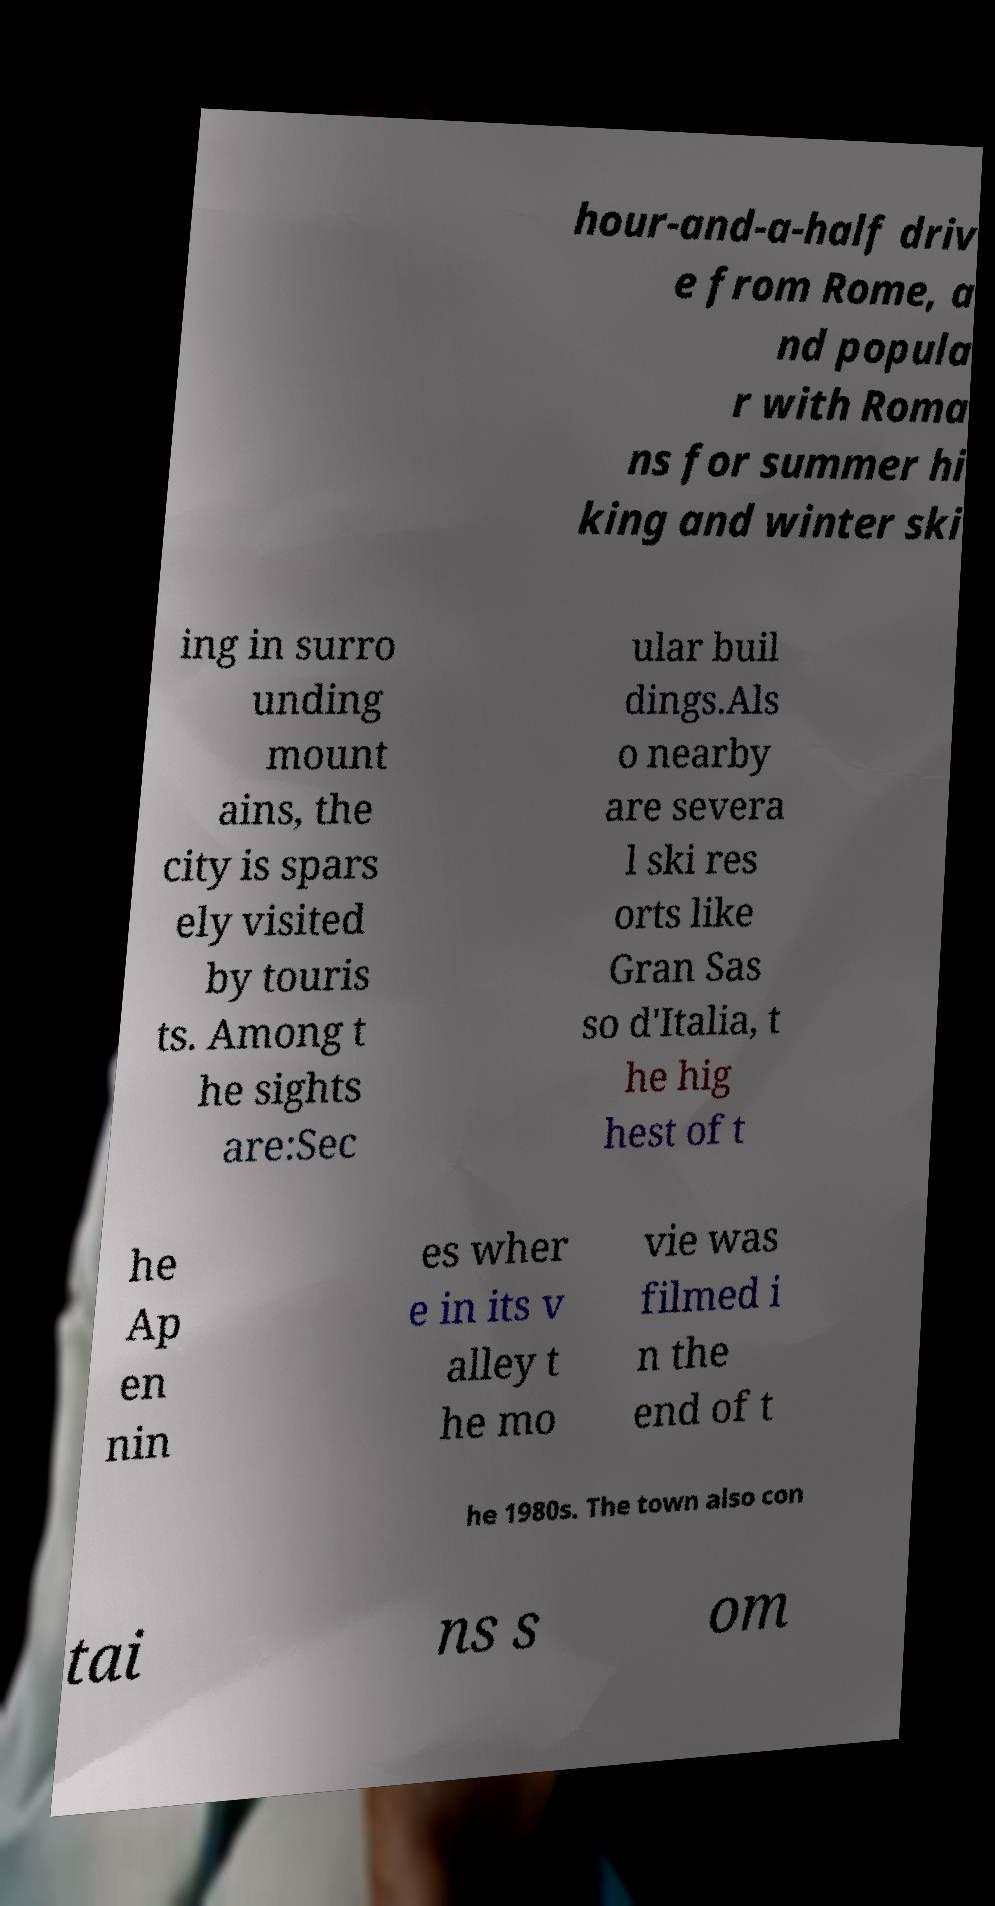Please identify and transcribe the text found in this image. hour-and-a-half driv e from Rome, a nd popula r with Roma ns for summer hi king and winter ski ing in surro unding mount ains, the city is spars ely visited by touris ts. Among t he sights are:Sec ular buil dings.Als o nearby are severa l ski res orts like Gran Sas so d'Italia, t he hig hest of t he Ap en nin es wher e in its v alley t he mo vie was filmed i n the end of t he 1980s. The town also con tai ns s om 